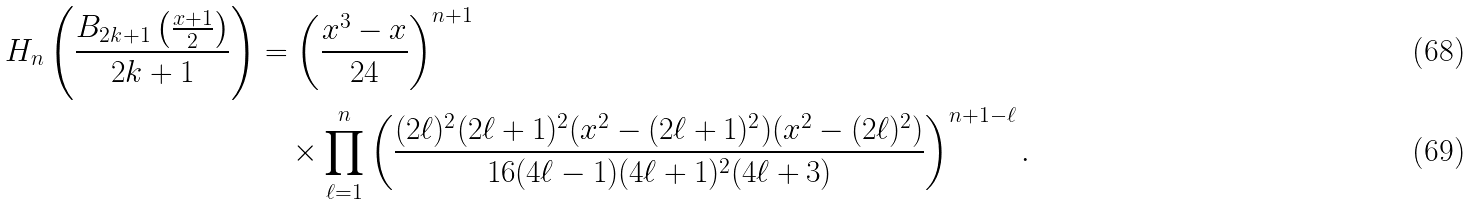<formula> <loc_0><loc_0><loc_500><loc_500>H _ { n } \left ( \frac { B _ { 2 k + 1 } \left ( \frac { x + 1 } { 2 } \right ) } { 2 k + 1 } \right ) & = \left ( \frac { x ^ { 3 } - x } { 2 4 } \right ) ^ { n + 1 } \\ & \quad \times \prod _ { \ell = 1 } ^ { n } \left ( \frac { ( 2 \ell ) ^ { 2 } ( 2 \ell + 1 ) ^ { 2 } ( x ^ { 2 } - ( 2 \ell + 1 ) ^ { 2 } ) ( x ^ { 2 } - ( 2 \ell ) ^ { 2 } ) } { 1 6 ( 4 \ell - 1 ) ( 4 \ell + 1 ) ^ { 2 } ( 4 \ell + 3 ) } \right ) ^ { n + 1 - \ell } .</formula> 